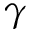Convert formula to latex. <formula><loc_0><loc_0><loc_500><loc_500>\gamma</formula> 